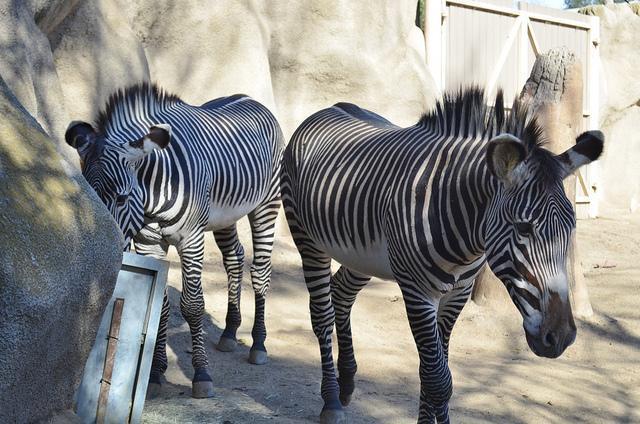How many zebras?
Give a very brief answer. 2. How many zebras are there?
Give a very brief answer. 2. How many bear arms are raised to the bears' ears?
Give a very brief answer. 0. 